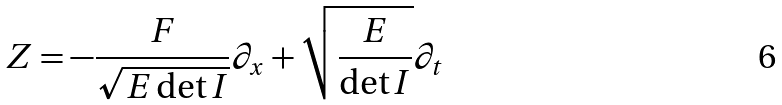<formula> <loc_0><loc_0><loc_500><loc_500>Z = - \frac { F } { \sqrt { E \det I } } \partial _ { x } + \sqrt { \frac { E } { \det I } } \partial _ { t }</formula> 